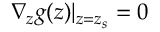<formula> <loc_0><loc_0><loc_500><loc_500>\nabla _ { z } g ( z ) | _ { z = z _ { s } } = 0</formula> 